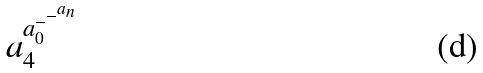<formula> <loc_0><loc_0><loc_500><loc_500>a _ { 4 } ^ { a _ { 0 } ^ { - ^ { - ^ { a _ { n } } } } }</formula> 